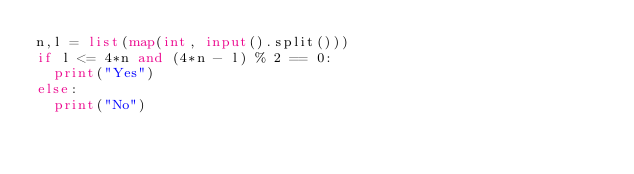<code> <loc_0><loc_0><loc_500><loc_500><_Python_>n,l = list(map(int, input().split()))
if l <= 4*n and (4*n - l) % 2 == 0:
  print("Yes")
else:
  print("No")</code> 